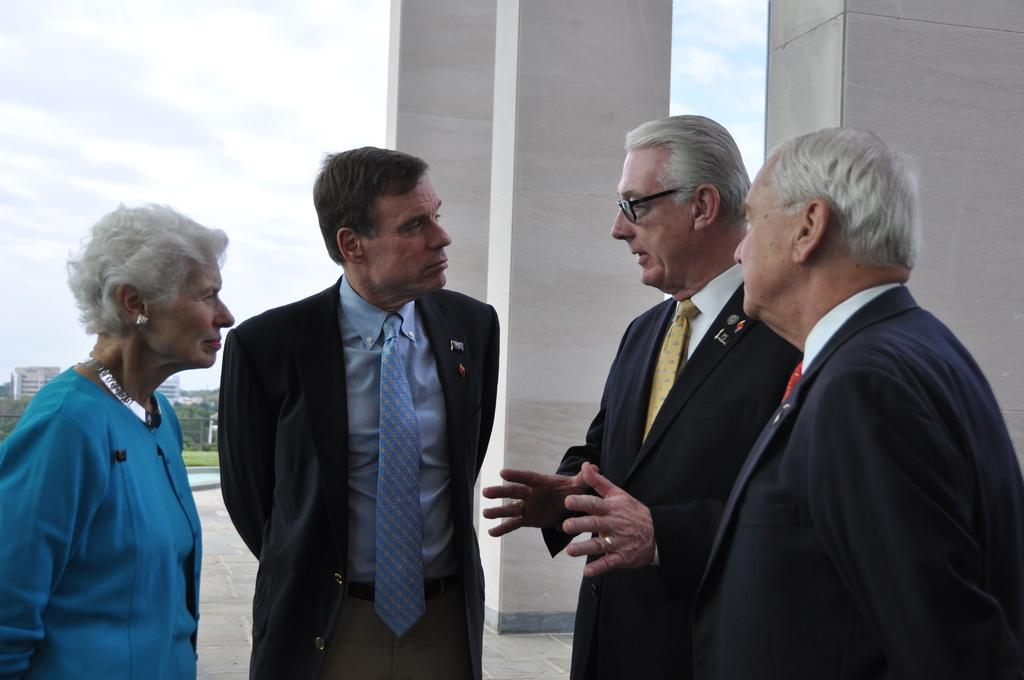How many people are in the image? There are three men and a woman in the image, making a total of four people. What is the position of the people in the image? They are standing on the ground. What architectural features can be seen in the image? There are pillars in the image. What can be seen in the background of the image? There are buildings, trees, a fence, and the sky visible in the background of the image. What is the condition of the sky in the image? The sky is visible in the background of the image, and clouds are present. What type of waste can be seen in the image? There is no waste present in the image. What decision is the woman making in the image? There is no indication of a decision being made in the image. 